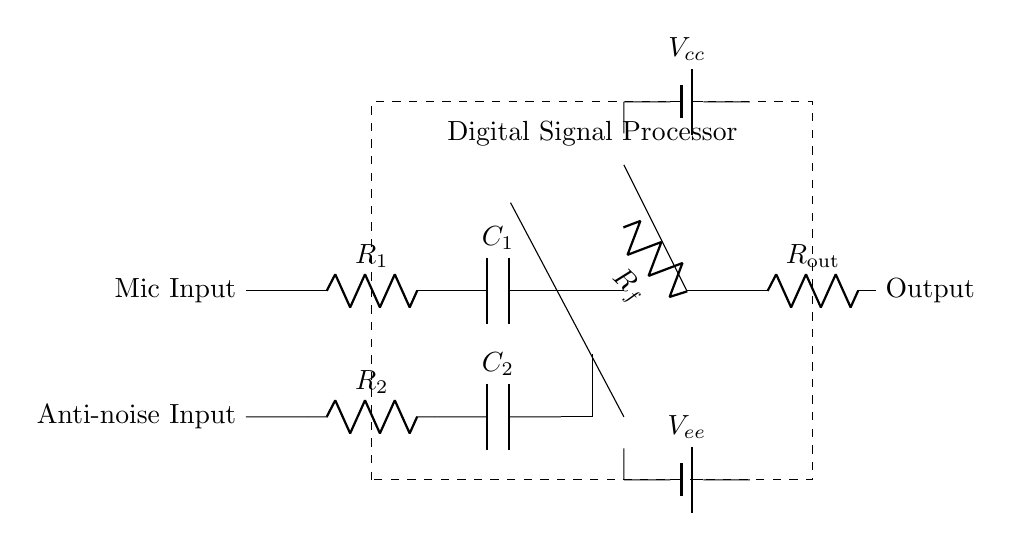What is the primary function of the operational amplifier in this circuit? The operational amplifier amplifies the difference between its input signals, which is essential for noise cancellation by increasing desired audio signals relative to unwanted noise.
Answer: Amplification What type of components are in series with the microphone input? The microphone input connects to a resistor followed by a capacitor, which are arranged in series to filter and condition the audio signal before further processing.
Answer: Resistor and capacitor Which component is used for powering the circuit? The circuit uses two batteries labeled as V cc and V ee to provide the necessary dual-polarity power supply for optimal operation of the operational amplifier and other components.
Answer: Batteries How many resistors are present in the circuit? There are three resistors present: R1, R2, and R out, which are used for input impedance setting, noise cancellation feedback, and output buffering respectively.
Answer: Three What is the purpose of the Digital Signal Processor in this noise cancellation circuit? The DSP processes the audio signals by applying algorithms for noise reduction, actively creating anti-noise signals that interfere with unwanted sounds, enhancing audio quality for the user.
Answer: Noise processing What would happen if R f were removed from the circuit? Removing R f would eliminate the feedback path, leading to potential instability in the gain of the operational amplifier, which might cause distortion of the output audio signal or excessive noise.
Answer: Instability 